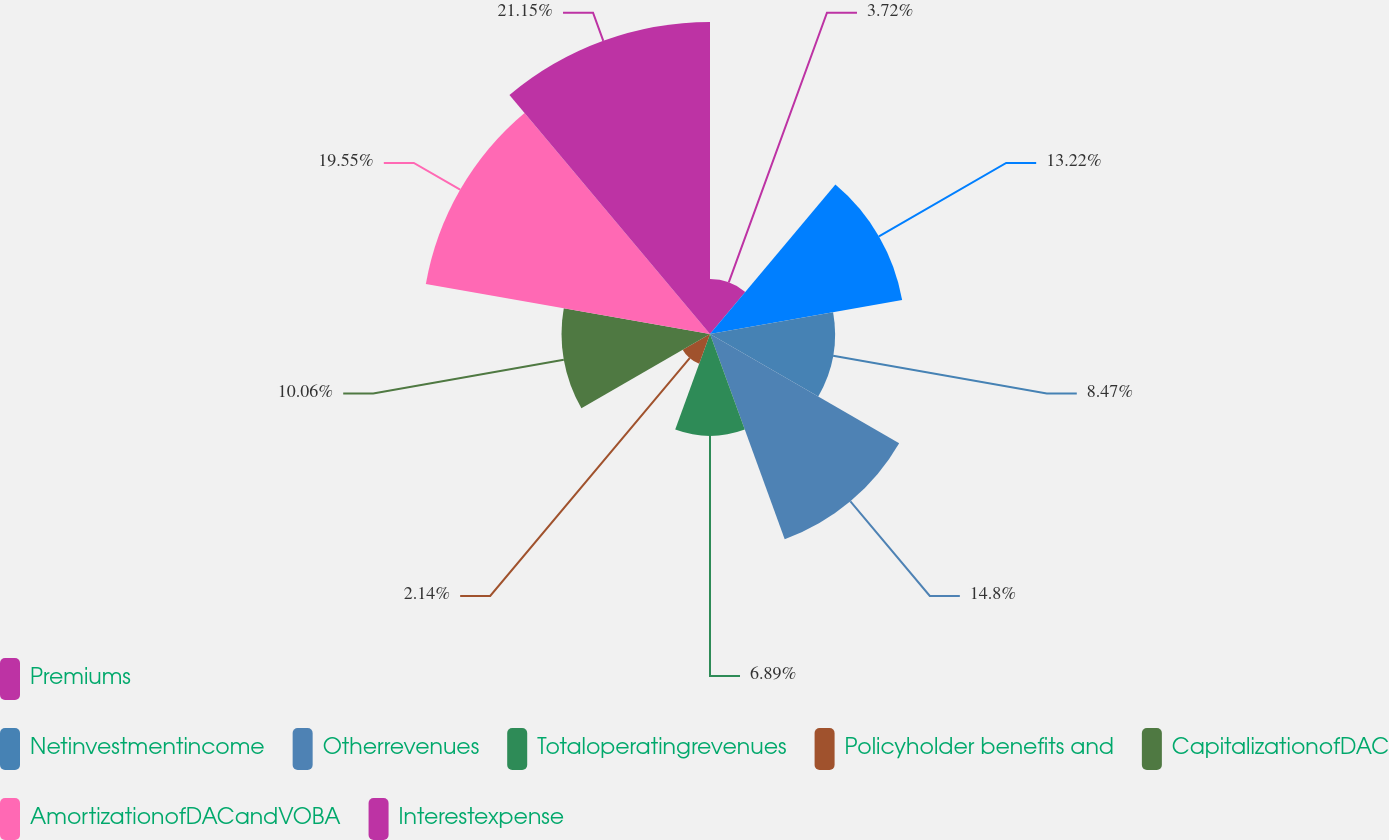Convert chart. <chart><loc_0><loc_0><loc_500><loc_500><pie_chart><fcel>Premiums<fcel>Unnamed: 1<fcel>Netinvestmentincome<fcel>Otherrevenues<fcel>Totaloperatingrevenues<fcel>Policyholder benefits and<fcel>CapitalizationofDAC<fcel>AmortizationofDACandVOBA<fcel>Interestexpense<nl><fcel>3.72%<fcel>13.22%<fcel>8.47%<fcel>14.8%<fcel>6.89%<fcel>2.14%<fcel>10.06%<fcel>19.55%<fcel>21.14%<nl></chart> 